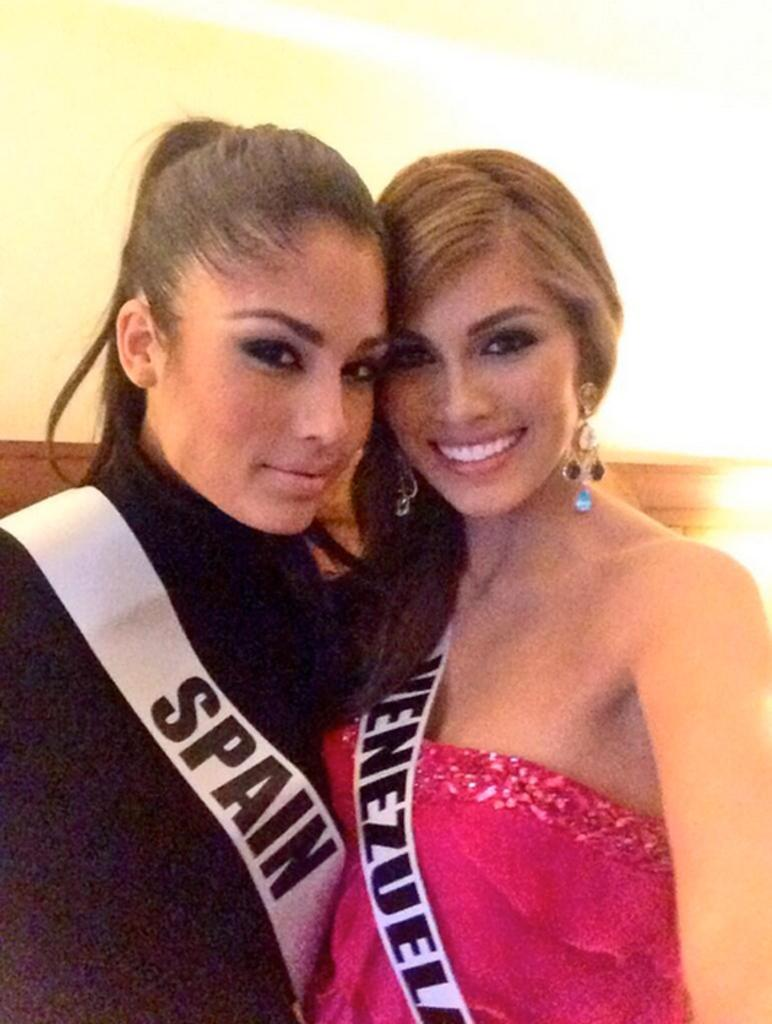<image>
Create a compact narrative representing the image presented. The woman on the left is wearing a banner signifying she is from Spain. 